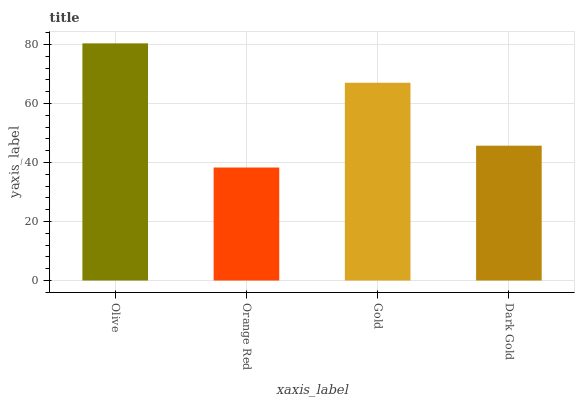Is Orange Red the minimum?
Answer yes or no. Yes. Is Olive the maximum?
Answer yes or no. Yes. Is Gold the minimum?
Answer yes or no. No. Is Gold the maximum?
Answer yes or no. No. Is Gold greater than Orange Red?
Answer yes or no. Yes. Is Orange Red less than Gold?
Answer yes or no. Yes. Is Orange Red greater than Gold?
Answer yes or no. No. Is Gold less than Orange Red?
Answer yes or no. No. Is Gold the high median?
Answer yes or no. Yes. Is Dark Gold the low median?
Answer yes or no. Yes. Is Dark Gold the high median?
Answer yes or no. No. Is Olive the low median?
Answer yes or no. No. 